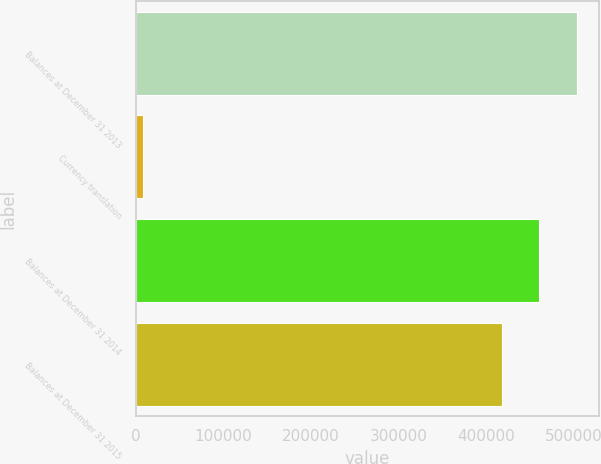Convert chart. <chart><loc_0><loc_0><loc_500><loc_500><bar_chart><fcel>Balances at December 31 2013<fcel>Currency translation<fcel>Balances at December 31 2014<fcel>Balances at December 31 2015<nl><fcel>503536<fcel>8002<fcel>460866<fcel>418197<nl></chart> 